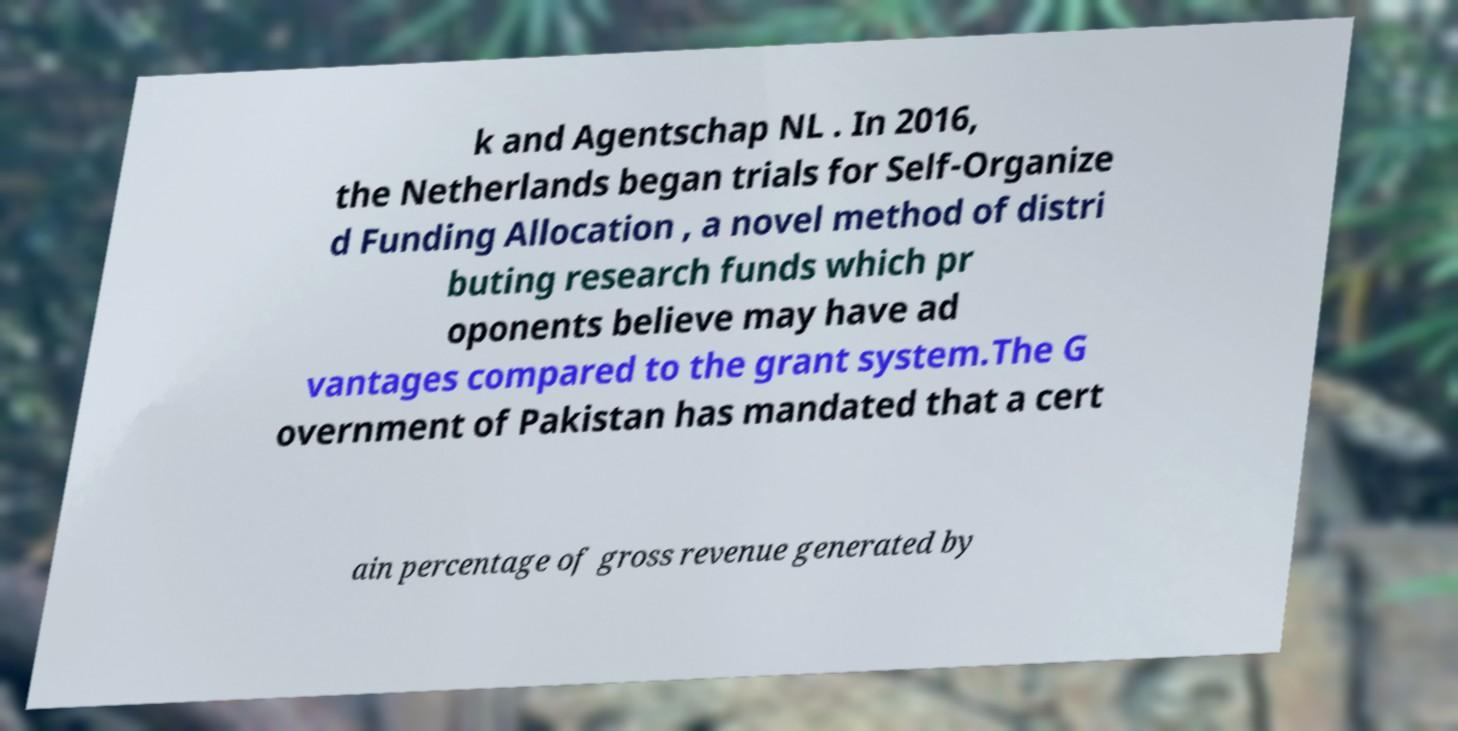Can you read and provide the text displayed in the image?This photo seems to have some interesting text. Can you extract and type it out for me? k and Agentschap NL . In 2016, the Netherlands began trials for Self-Organize d Funding Allocation , a novel method of distri buting research funds which pr oponents believe may have ad vantages compared to the grant system.The G overnment of Pakistan has mandated that a cert ain percentage of gross revenue generated by 